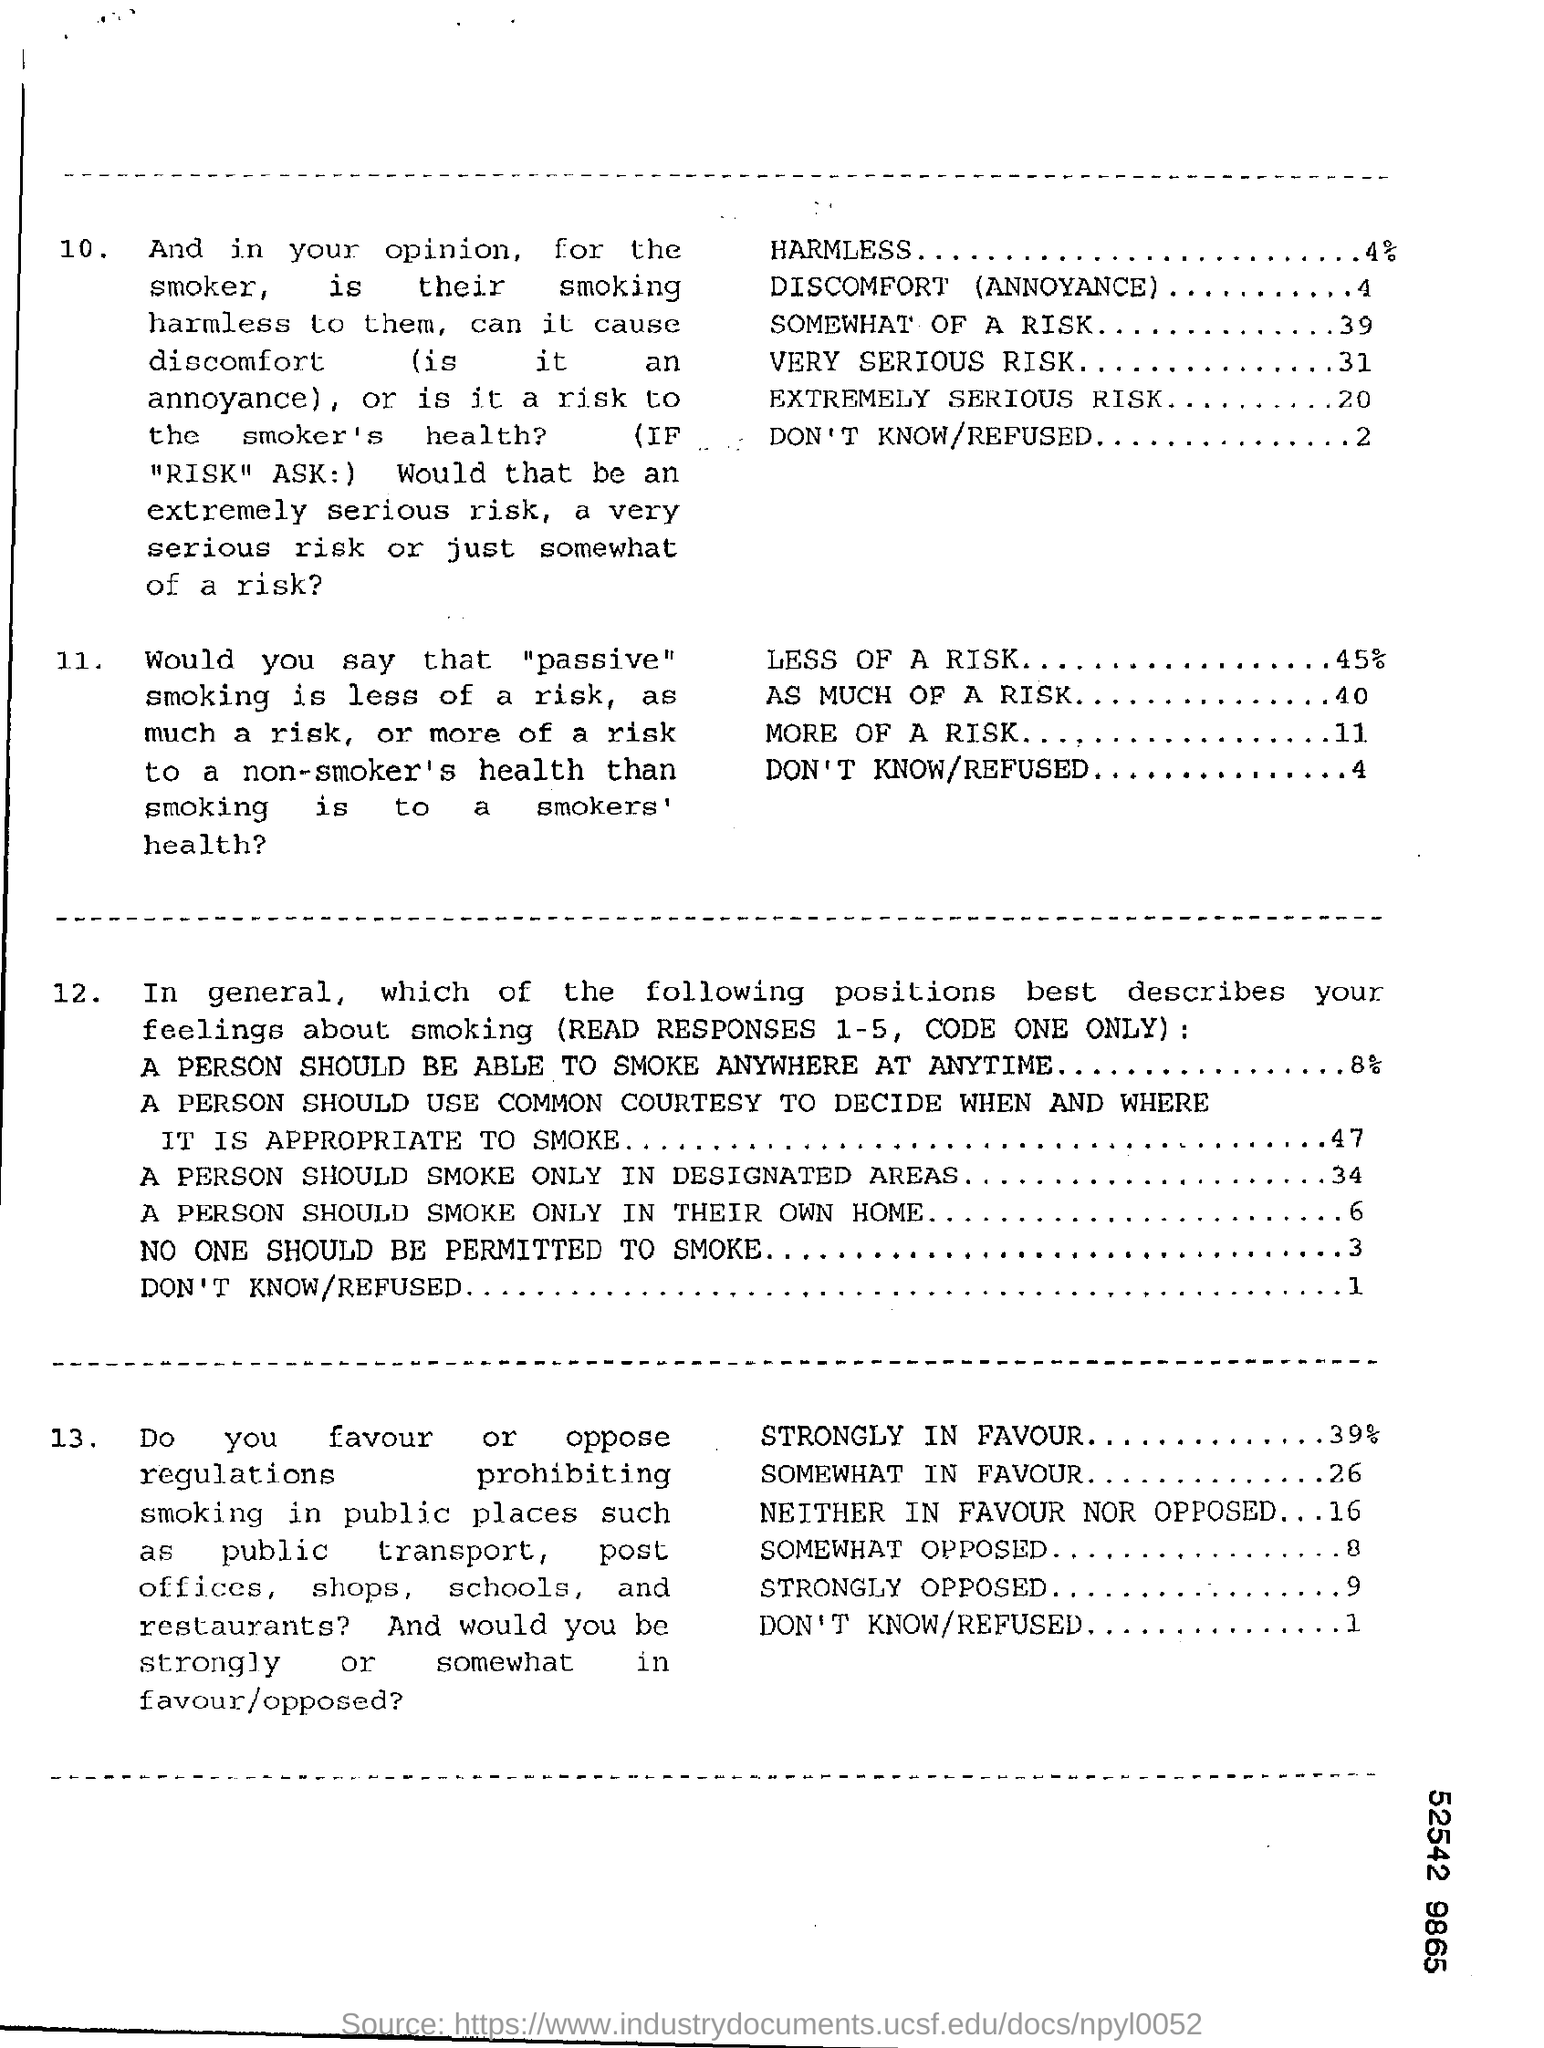What is the percentage for "Harmless"?
Offer a terse response. 4%. What is the percentage for "Less of a Risk"?
Keep it short and to the point. 45%. What is the value for "More of a Risk"?
Provide a short and direct response. 11. What is the value for "Very Serious Risk"?
Keep it short and to the point. 31. What is the percentage for "Strongly in Favour"?
Offer a terse response. 39%. What is the value for "Somewhat Opposed"?
Your response must be concise. 8. What is the value for "Strongly Opposed"?
Your answer should be compact. 9. 